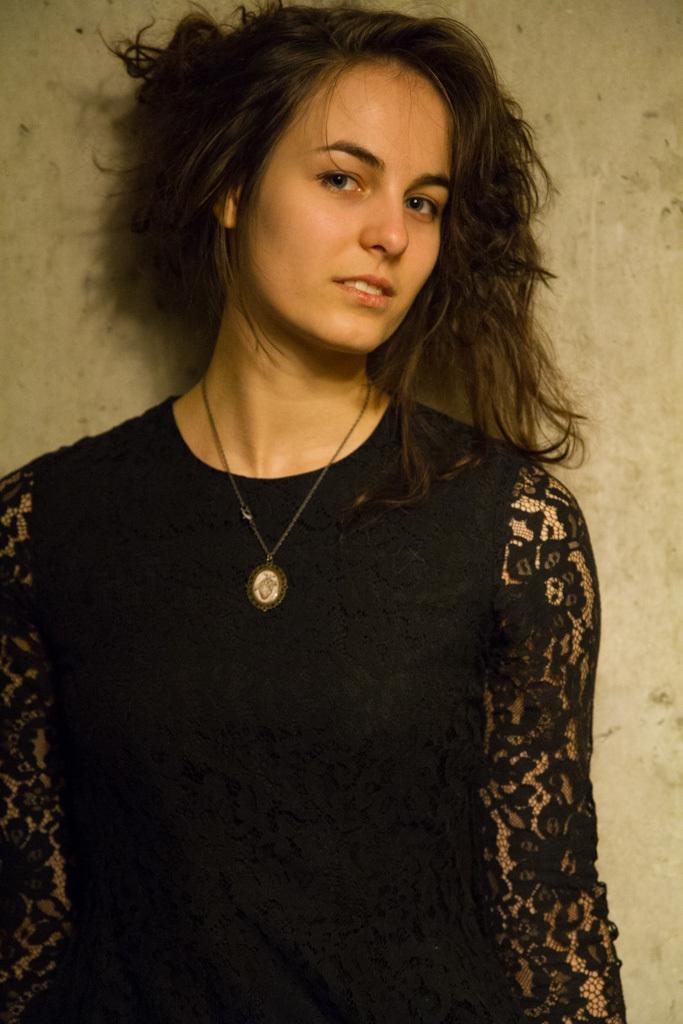In one or two sentences, can you explain what this image depicts? In this picture there is a person standing, behind this person we can see wall. 